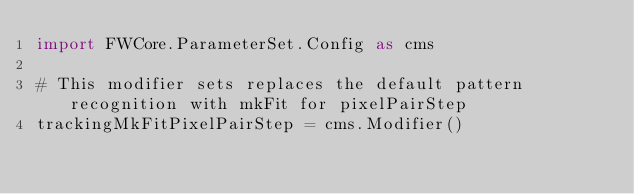Convert code to text. <code><loc_0><loc_0><loc_500><loc_500><_Python_>import FWCore.ParameterSet.Config as cms

# This modifier sets replaces the default pattern recognition with mkFit for pixelPairStep
trackingMkFitPixelPairStep = cms.Modifier()
</code> 